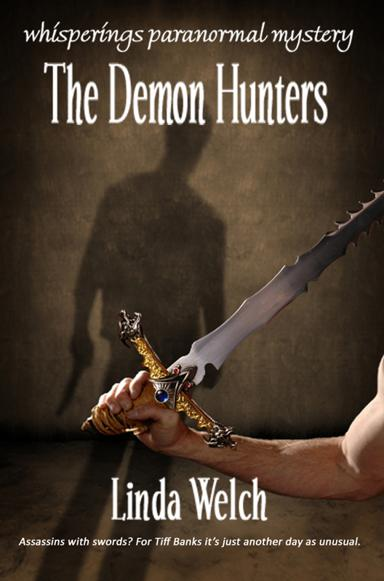What mood is conveyed by the colors and shadows used on the book's cover? The cover employs a muted palette with dominant shades of brown and shadowy contours, evoking a mood of mystery and impending danger. This artistic choice sets a somber tone that complements the book's thrilling and suspenseful narrative. How might this affect a reader's anticipation before reading the book? This visual strategy likely stirs a reader's curiosity and heightens their anticipation, priming them for a gripping tale of paranormal activities and unseen threats. It visually promises an engaging adventure, potentially increasing the reader's emotional investment even before the story begins. 